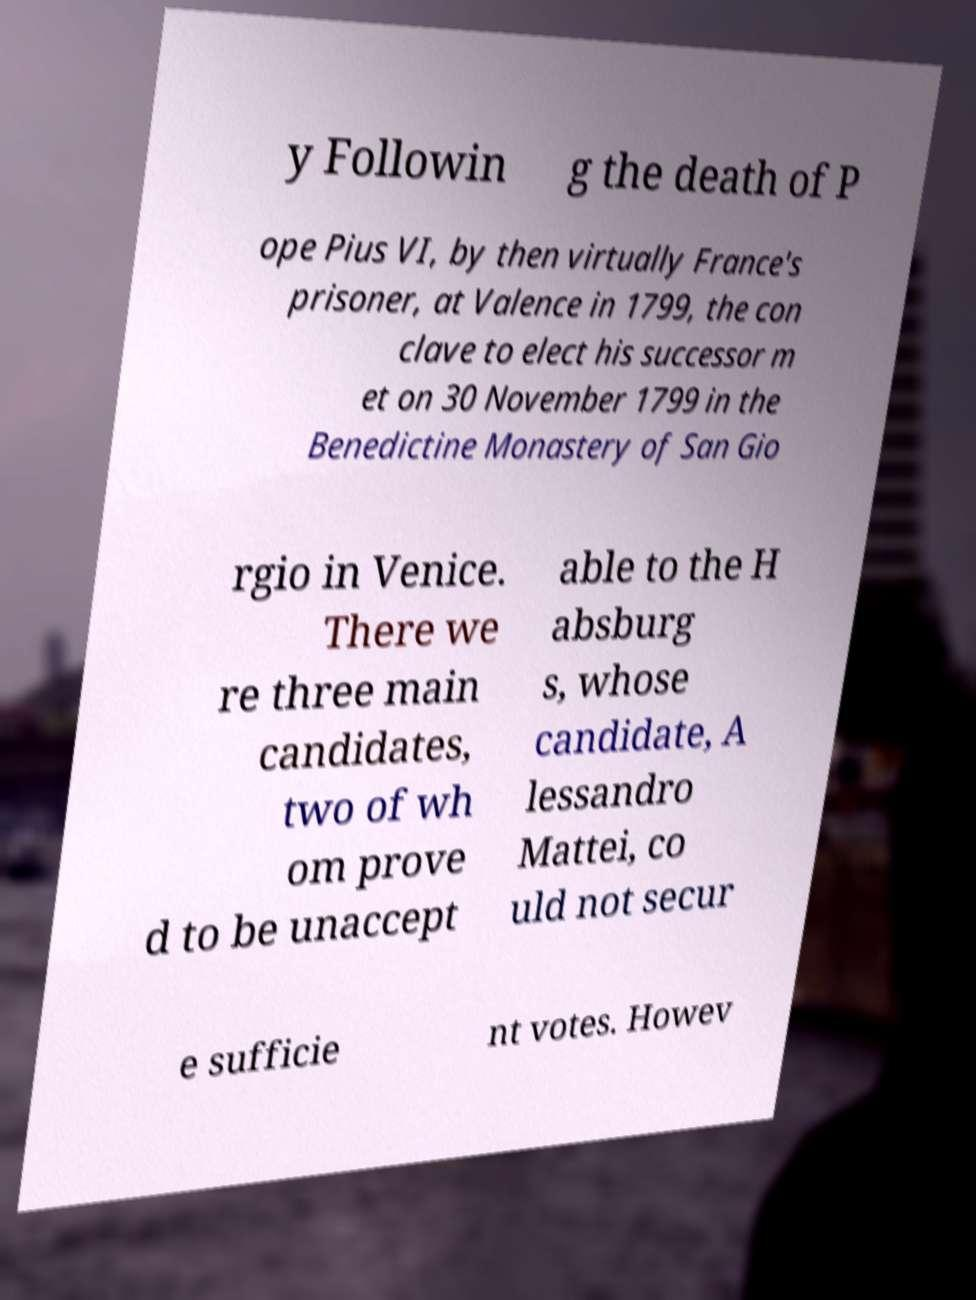There's text embedded in this image that I need extracted. Can you transcribe it verbatim? y Followin g the death of P ope Pius VI, by then virtually France's prisoner, at Valence in 1799, the con clave to elect his successor m et on 30 November 1799 in the Benedictine Monastery of San Gio rgio in Venice. There we re three main candidates, two of wh om prove d to be unaccept able to the H absburg s, whose candidate, A lessandro Mattei, co uld not secur e sufficie nt votes. Howev 